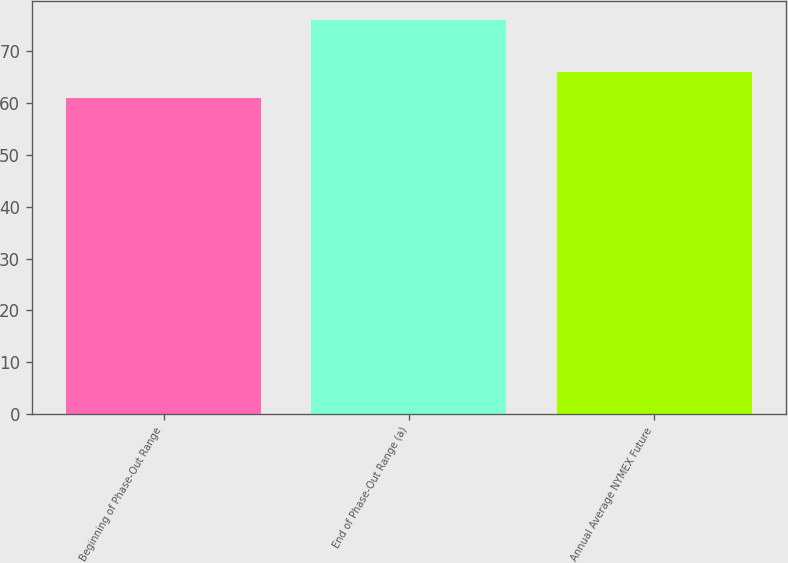<chart> <loc_0><loc_0><loc_500><loc_500><bar_chart><fcel>Beginning of Phase-Out Range<fcel>End of Phase-Out Range (a)<fcel>Annual Average NYMEX Future<nl><fcel>61<fcel>76<fcel>66<nl></chart> 